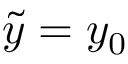Convert formula to latex. <formula><loc_0><loc_0><loc_500><loc_500>\tilde { y } = y _ { 0 }</formula> 